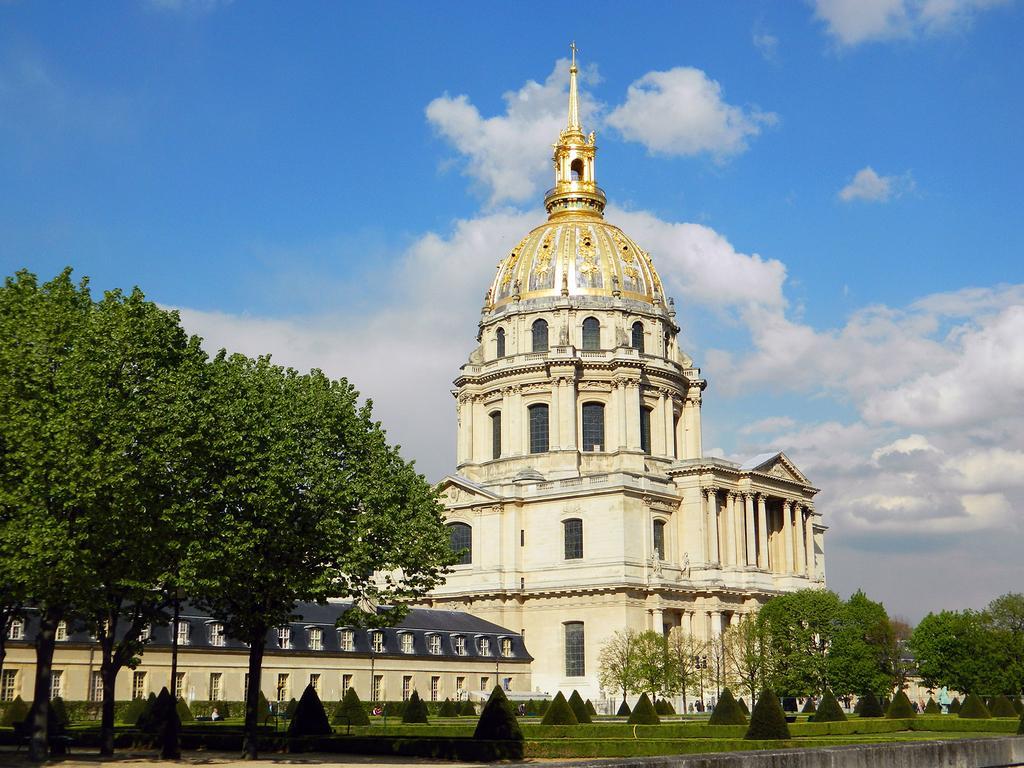Can you describe this image briefly? In the center of the image there is a building. On the right side of the image there are trees. On the left side of the image there are trees. At the bottom of the image we can see grass and plants. In the background there is a sky and clouds. 